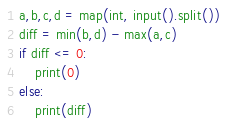<code> <loc_0><loc_0><loc_500><loc_500><_Python_>a,b,c,d = map(int, input().split())
diff = min(b,d) - max(a,c)
if diff <= 0:
    print(0)
else:
    print(diff)</code> 